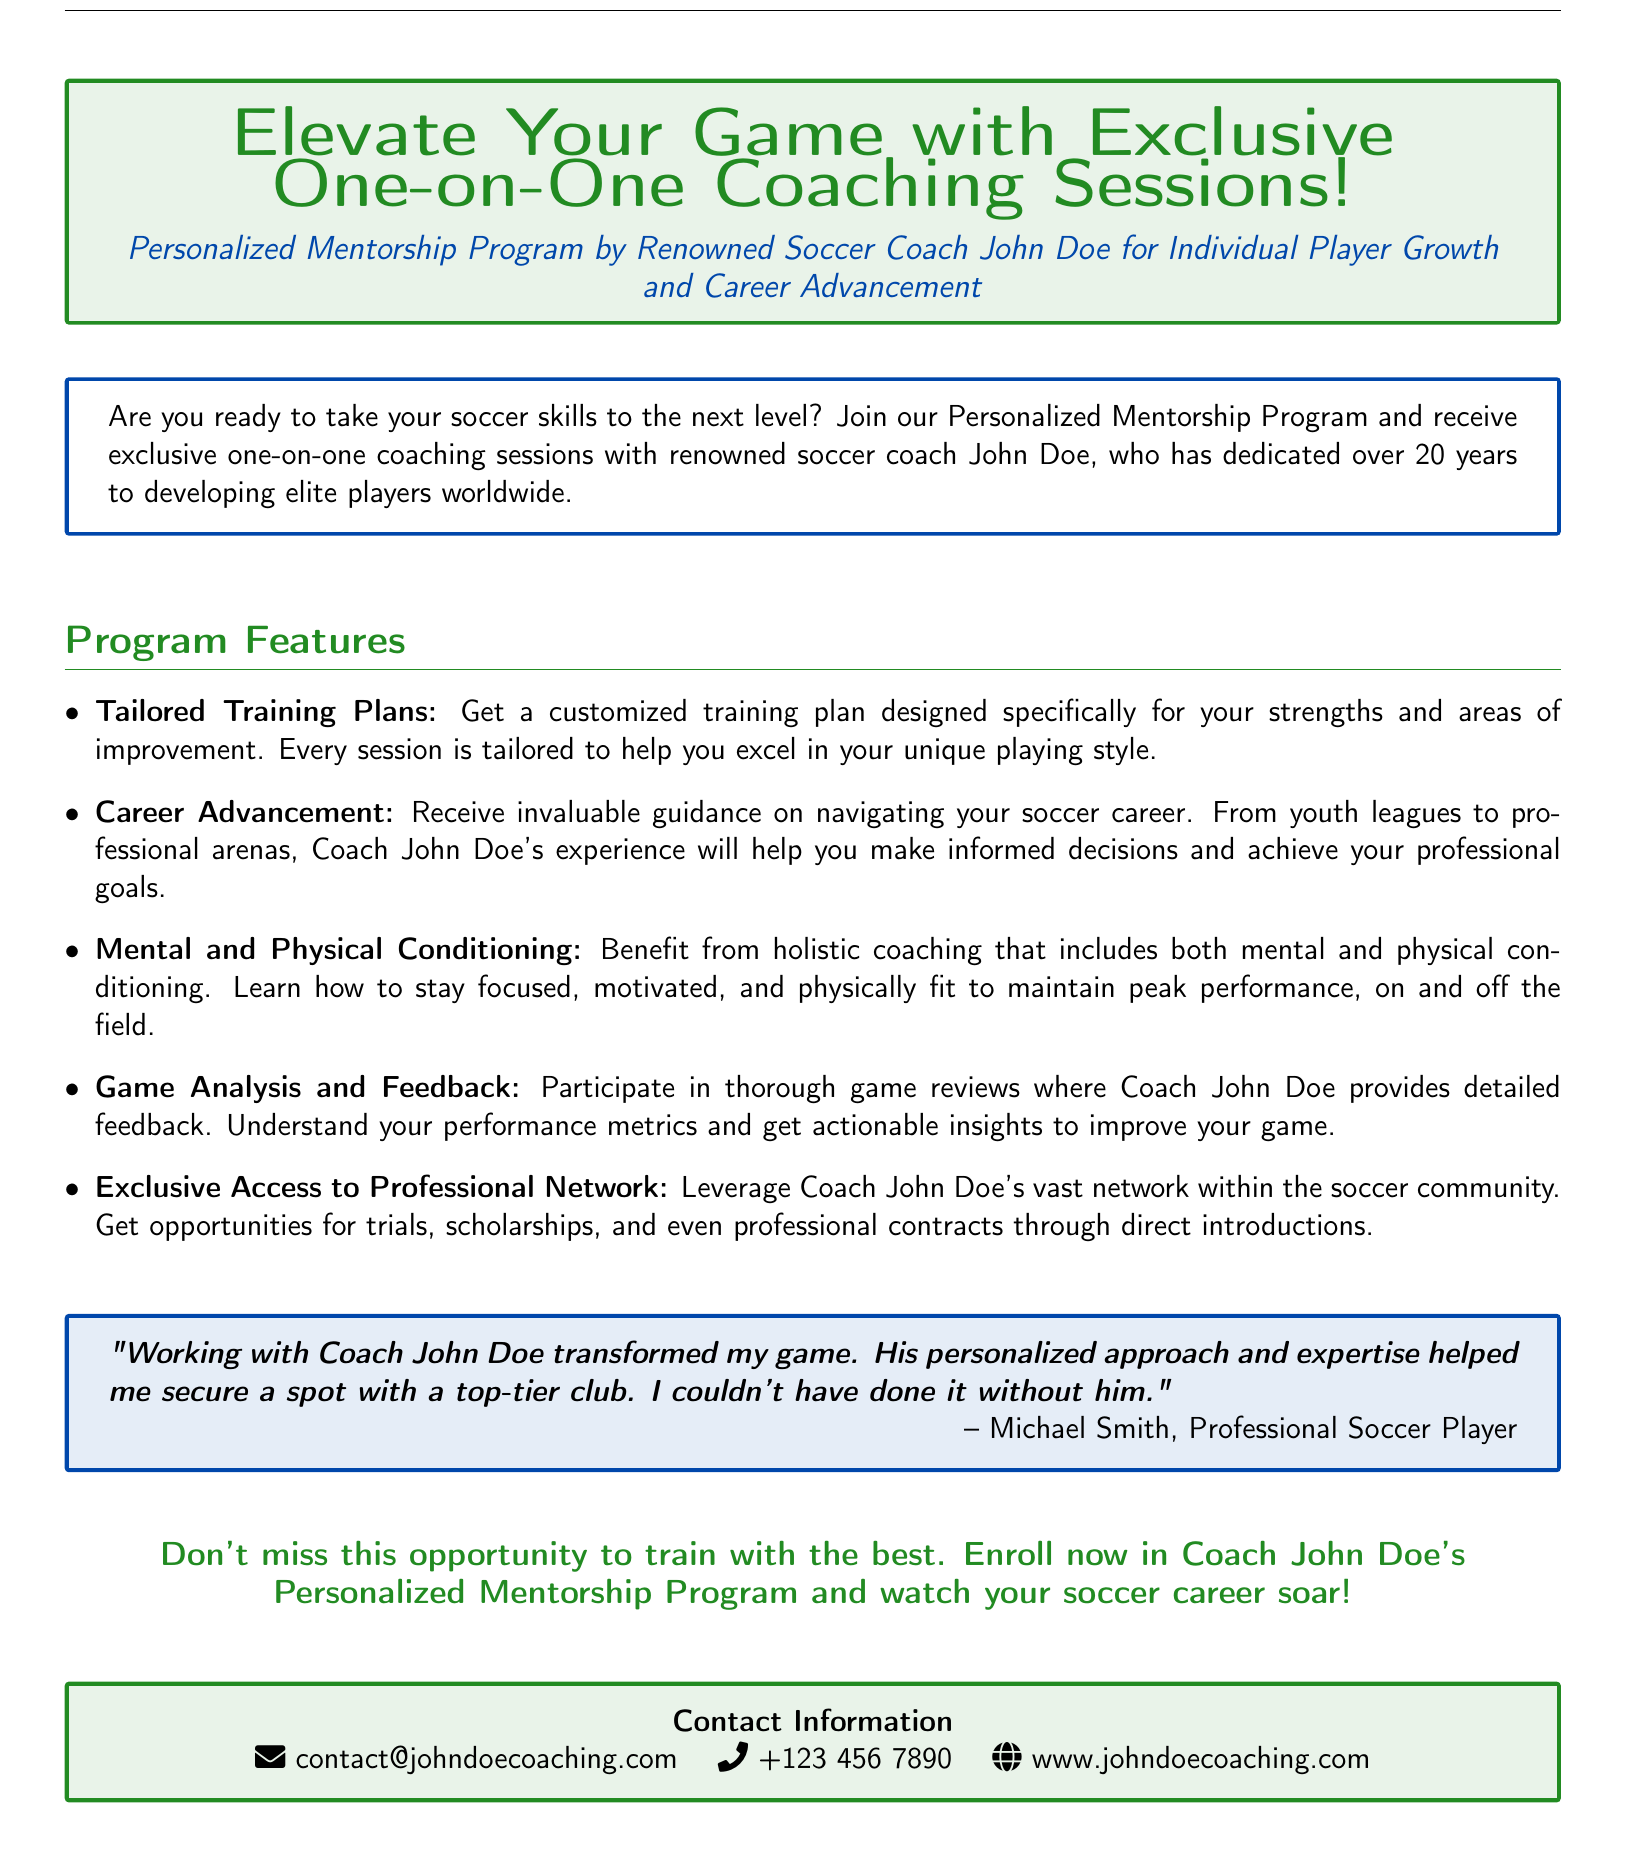What is the name of the renowned soccer coach? The document explicitly mentions the name of the coach, which is "John Doe".
Answer: John Doe How many years of experience does Coach John Doe have? The document states that Coach John Doe has dedicated over "20 years" to developing elite players worldwide.
Answer: 20 years What type of training plans are offered in the program? The document specifies that "Tailored Training Plans" are provided, indicating a customized approach.
Answer: Tailored Training Plans What is one benefit of participating in the game analysis? The document highlights that participants receive "detailed feedback" on their performance, indicating this is an advantage.
Answer: Detailed feedback What is the contact email provided in the document? The document lists the contact email as "contact@johndoecoaching.com".
Answer: contact@johndoecoaching.com What kind of coaching does the program include besides physical? The document mentions "mental" coaching as a holistic part of the training.
Answer: Mental Which testimonial is included in the advertisement? The document features a testimonial from "Michael Smith, Professional Soccer Player", providing social proof of the program's effectiveness.
Answer: Michael Smith What is the primary focus of the Personalized Mentorship Program? The document focuses on "Individual Player Growth and Career Advancement" as the main purpose of the program.
Answer: Individual Player Growth and Career Advancement 